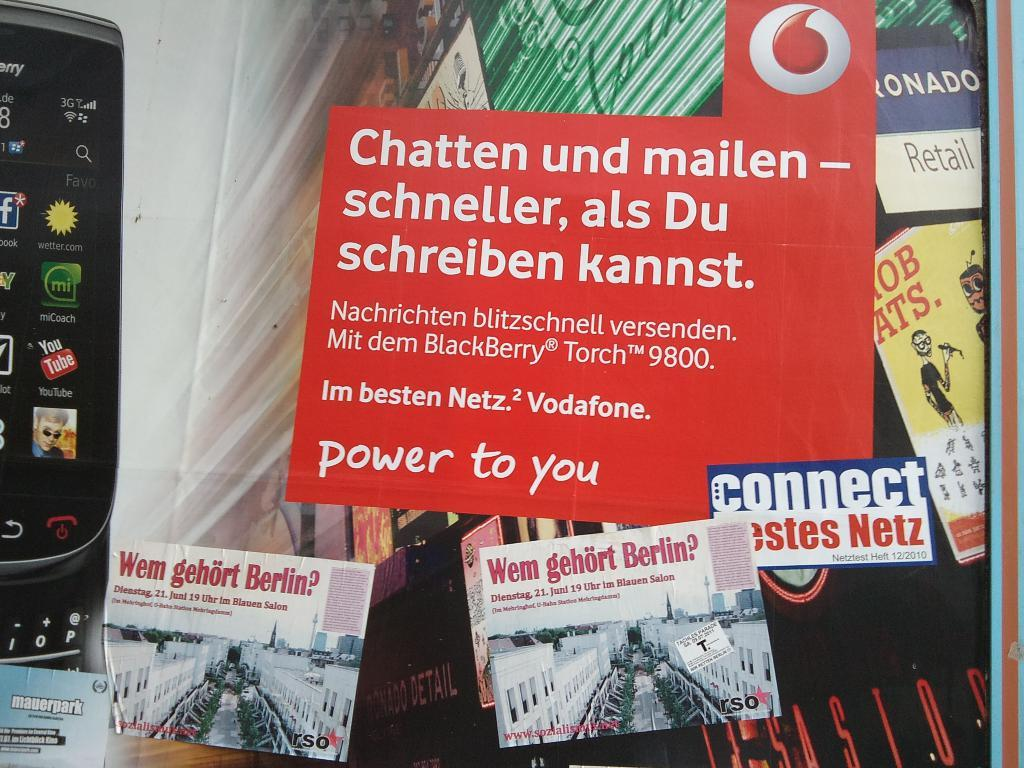<image>
Give a short and clear explanation of the subsequent image. A Wem Gehort Berlin sign and a Chatten und mailen sneller, als Du schreiben kannst sign. 